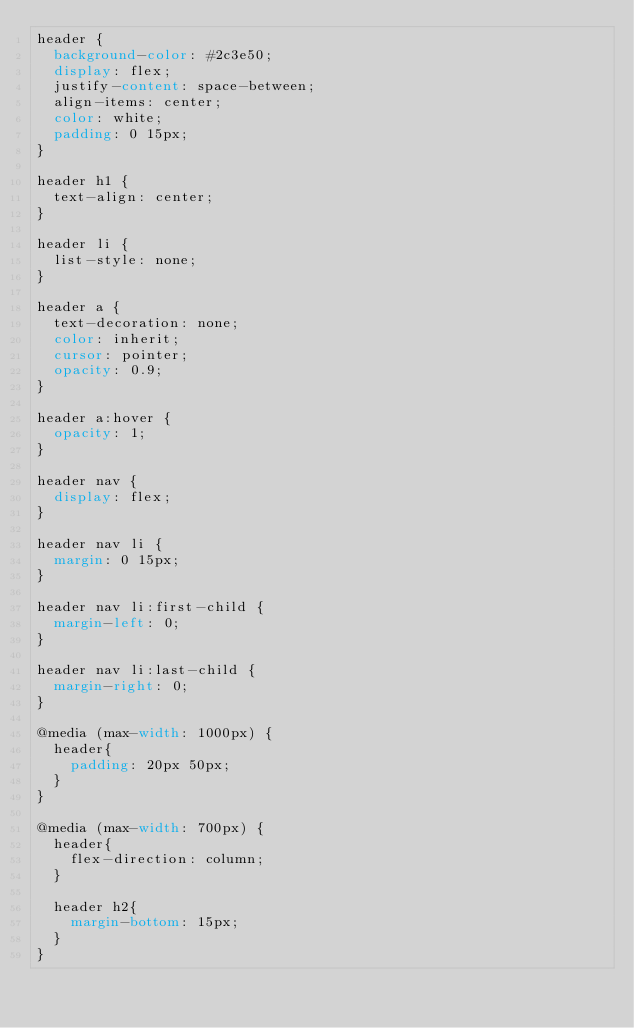Convert code to text. <code><loc_0><loc_0><loc_500><loc_500><_CSS_>header {
  background-color: #2c3e50;
  display: flex;
  justify-content: space-between;
  align-items: center;
  color: white;
  padding: 0 15px;
}

header h1 {
  text-align: center;
}

header li {
  list-style: none;
}

header a {
  text-decoration: none;
  color: inherit;
  cursor: pointer;
  opacity: 0.9;
}

header a:hover {
  opacity: 1;
}

header nav {
  display: flex;
}

header nav li {
  margin: 0 15px;
}

header nav li:first-child {
  margin-left: 0;
}

header nav li:last-child {
  margin-right: 0;
}

@media (max-width: 1000px) {
  header{
    padding: 20px 50px;
  }
}

@media (max-width: 700px) {
  header{
    flex-direction: column;
  }

  header h2{
    margin-bottom: 15px;
  }
}</code> 